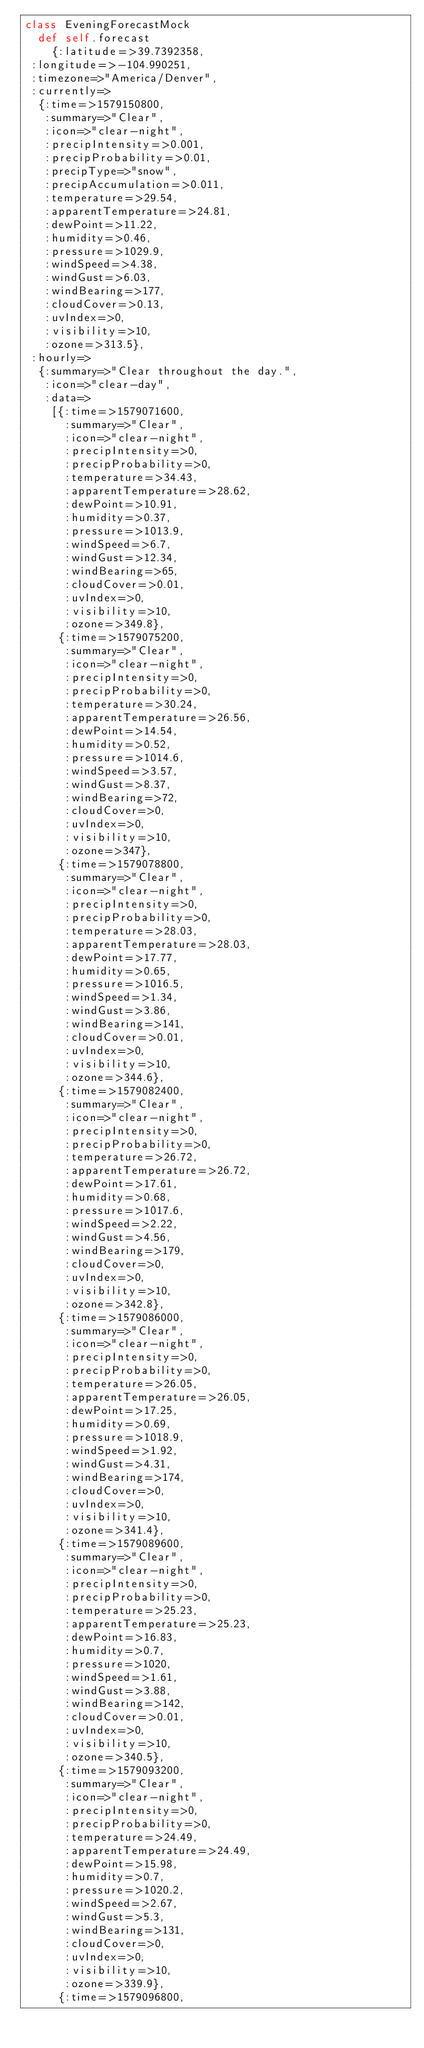Convert code to text. <code><loc_0><loc_0><loc_500><loc_500><_Ruby_>class EveningForecastMock
  def self.forecast
    {:latitude=>39.7392358,
 :longitude=>-104.990251,
 :timezone=>"America/Denver",
 :currently=>
  {:time=>1579150800,
   :summary=>"Clear",
   :icon=>"clear-night",
   :precipIntensity=>0.001,
   :precipProbability=>0.01,
   :precipType=>"snow",
   :precipAccumulation=>0.011,
   :temperature=>29.54,
   :apparentTemperature=>24.81,
   :dewPoint=>11.22,
   :humidity=>0.46,
   :pressure=>1029.9,
   :windSpeed=>4.38,
   :windGust=>6.03,
   :windBearing=>177,
   :cloudCover=>0.13,
   :uvIndex=>0,
   :visibility=>10,
   :ozone=>313.5},
 :hourly=>
  {:summary=>"Clear throughout the day.",
   :icon=>"clear-day",
   :data=>
    [{:time=>1579071600,
      :summary=>"Clear",
      :icon=>"clear-night",
      :precipIntensity=>0,
      :precipProbability=>0,
      :temperature=>34.43,
      :apparentTemperature=>28.62,
      :dewPoint=>10.91,
      :humidity=>0.37,
      :pressure=>1013.9,
      :windSpeed=>6.7,
      :windGust=>12.34,
      :windBearing=>65,
      :cloudCover=>0.01,
      :uvIndex=>0,
      :visibility=>10,
      :ozone=>349.8},
     {:time=>1579075200,
      :summary=>"Clear",
      :icon=>"clear-night",
      :precipIntensity=>0,
      :precipProbability=>0,
      :temperature=>30.24,
      :apparentTemperature=>26.56,
      :dewPoint=>14.54,
      :humidity=>0.52,
      :pressure=>1014.6,
      :windSpeed=>3.57,
      :windGust=>8.37,
      :windBearing=>72,
      :cloudCover=>0,
      :uvIndex=>0,
      :visibility=>10,
      :ozone=>347},
     {:time=>1579078800,
      :summary=>"Clear",
      :icon=>"clear-night",
      :precipIntensity=>0,
      :precipProbability=>0,
      :temperature=>28.03,
      :apparentTemperature=>28.03,
      :dewPoint=>17.77,
      :humidity=>0.65,
      :pressure=>1016.5,
      :windSpeed=>1.34,
      :windGust=>3.86,
      :windBearing=>141,
      :cloudCover=>0.01,
      :uvIndex=>0,
      :visibility=>10,
      :ozone=>344.6},
     {:time=>1579082400,
      :summary=>"Clear",
      :icon=>"clear-night",
      :precipIntensity=>0,
      :precipProbability=>0,
      :temperature=>26.72,
      :apparentTemperature=>26.72,
      :dewPoint=>17.61,
      :humidity=>0.68,
      :pressure=>1017.6,
      :windSpeed=>2.22,
      :windGust=>4.56,
      :windBearing=>179,
      :cloudCover=>0,
      :uvIndex=>0,
      :visibility=>10,
      :ozone=>342.8},
     {:time=>1579086000,
      :summary=>"Clear",
      :icon=>"clear-night",
      :precipIntensity=>0,
      :precipProbability=>0,
      :temperature=>26.05,
      :apparentTemperature=>26.05,
      :dewPoint=>17.25,
      :humidity=>0.69,
      :pressure=>1018.9,
      :windSpeed=>1.92,
      :windGust=>4.31,
      :windBearing=>174,
      :cloudCover=>0,
      :uvIndex=>0,
      :visibility=>10,
      :ozone=>341.4},
     {:time=>1579089600,
      :summary=>"Clear",
      :icon=>"clear-night",
      :precipIntensity=>0,
      :precipProbability=>0,
      :temperature=>25.23,
      :apparentTemperature=>25.23,
      :dewPoint=>16.83,
      :humidity=>0.7,
      :pressure=>1020,
      :windSpeed=>1.61,
      :windGust=>3.88,
      :windBearing=>142,
      :cloudCover=>0.01,
      :uvIndex=>0,
      :visibility=>10,
      :ozone=>340.5},
     {:time=>1579093200,
      :summary=>"Clear",
      :icon=>"clear-night",
      :precipIntensity=>0,
      :precipProbability=>0,
      :temperature=>24.49,
      :apparentTemperature=>24.49,
      :dewPoint=>15.98,
      :humidity=>0.7,
      :pressure=>1020.2,
      :windSpeed=>2.67,
      :windGust=>5.3,
      :windBearing=>131,
      :cloudCover=>0,
      :uvIndex=>0,
      :visibility=>10,
      :ozone=>339.9},
     {:time=>1579096800,</code> 